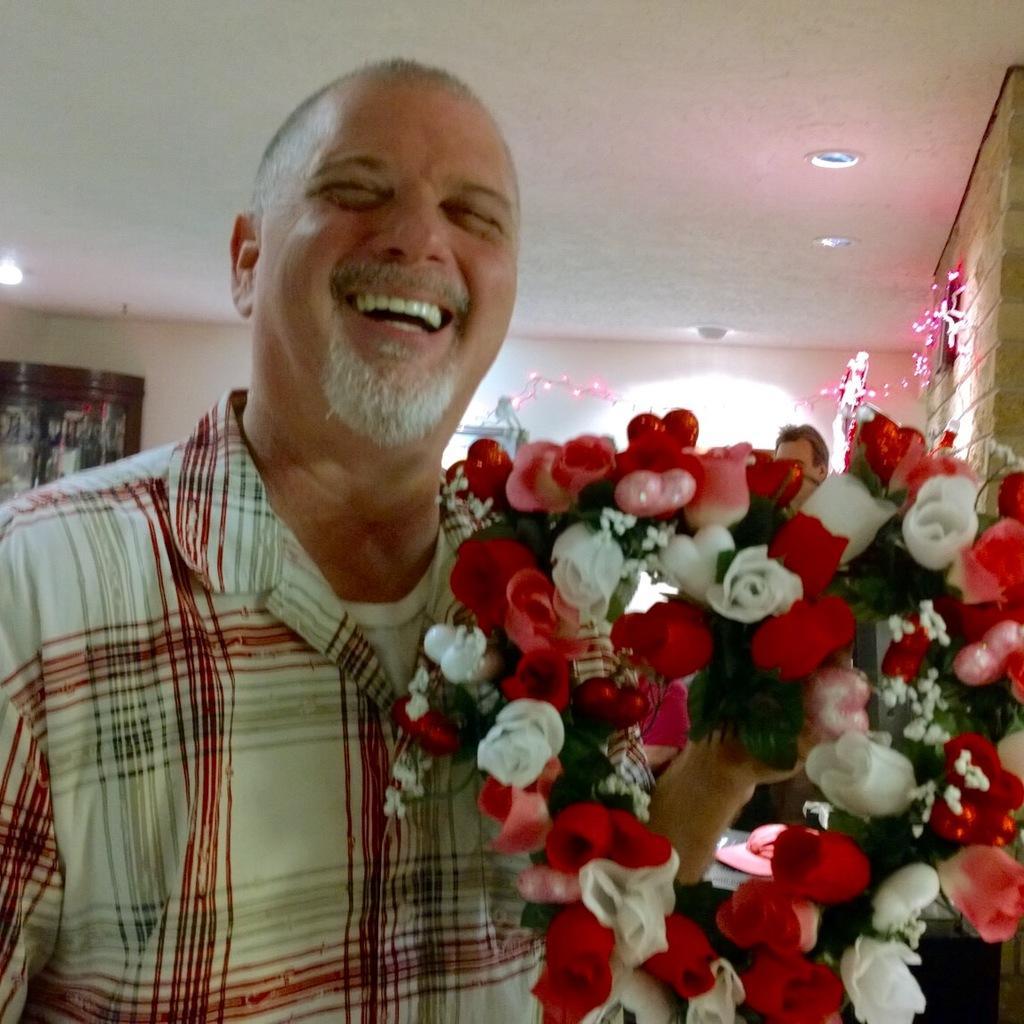Please provide a concise description of this image. In this image in front there is a person wearing a smile on his face and he is holding the bouquet. Behind him there is a table. On top of it there is a cap. Behind the table there is a person. In the background of the image there is a wall. There are decorative items. On the left side of the image there is some object. On top of the image there are lights. 